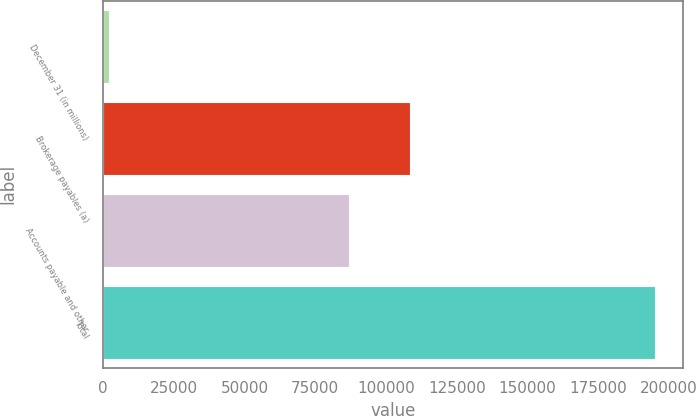Convert chart. <chart><loc_0><loc_0><loc_500><loc_500><bar_chart><fcel>December 31 (in millions)<fcel>Brokerage payables (a)<fcel>Accounts payable and other<fcel>Total<nl><fcel>2012<fcel>108398<fcel>86842<fcel>195240<nl></chart> 